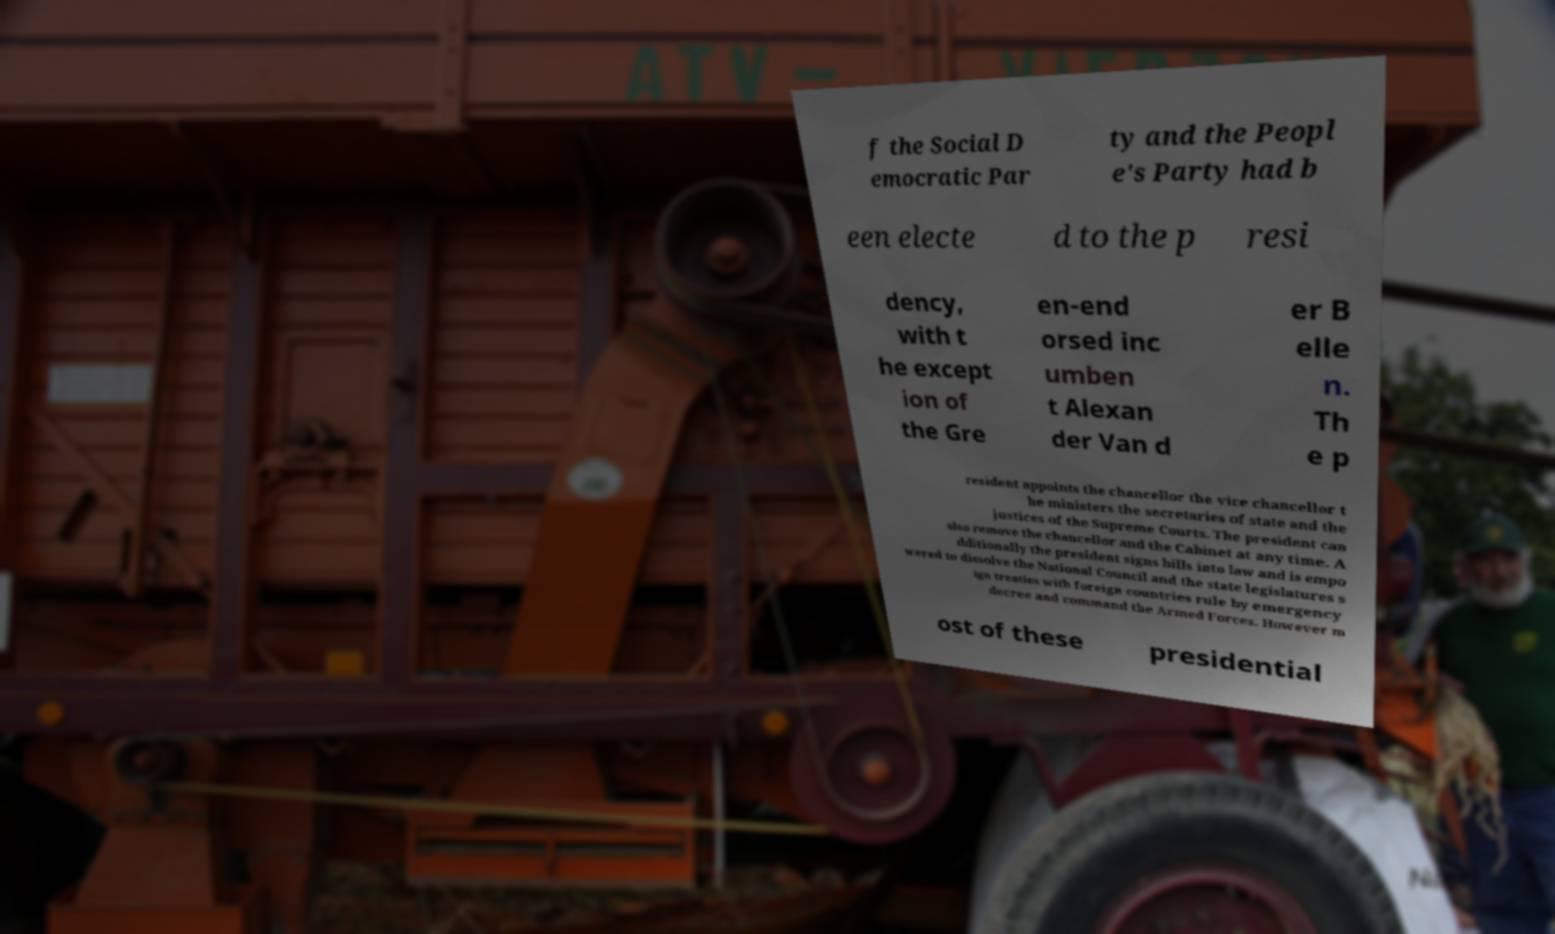Could you extract and type out the text from this image? f the Social D emocratic Par ty and the Peopl e's Party had b een electe d to the p resi dency, with t he except ion of the Gre en-end orsed inc umben t Alexan der Van d er B elle n. Th e p resident appoints the chancellor the vice chancellor t he ministers the secretaries of state and the justices of the Supreme Courts. The president can also remove the chancellor and the Cabinet at any time. A dditionally the president signs bills into law and is empo wered to dissolve the National Council and the state legislatures s ign treaties with foreign countries rule by emergency decree and command the Armed Forces. However m ost of these presidential 